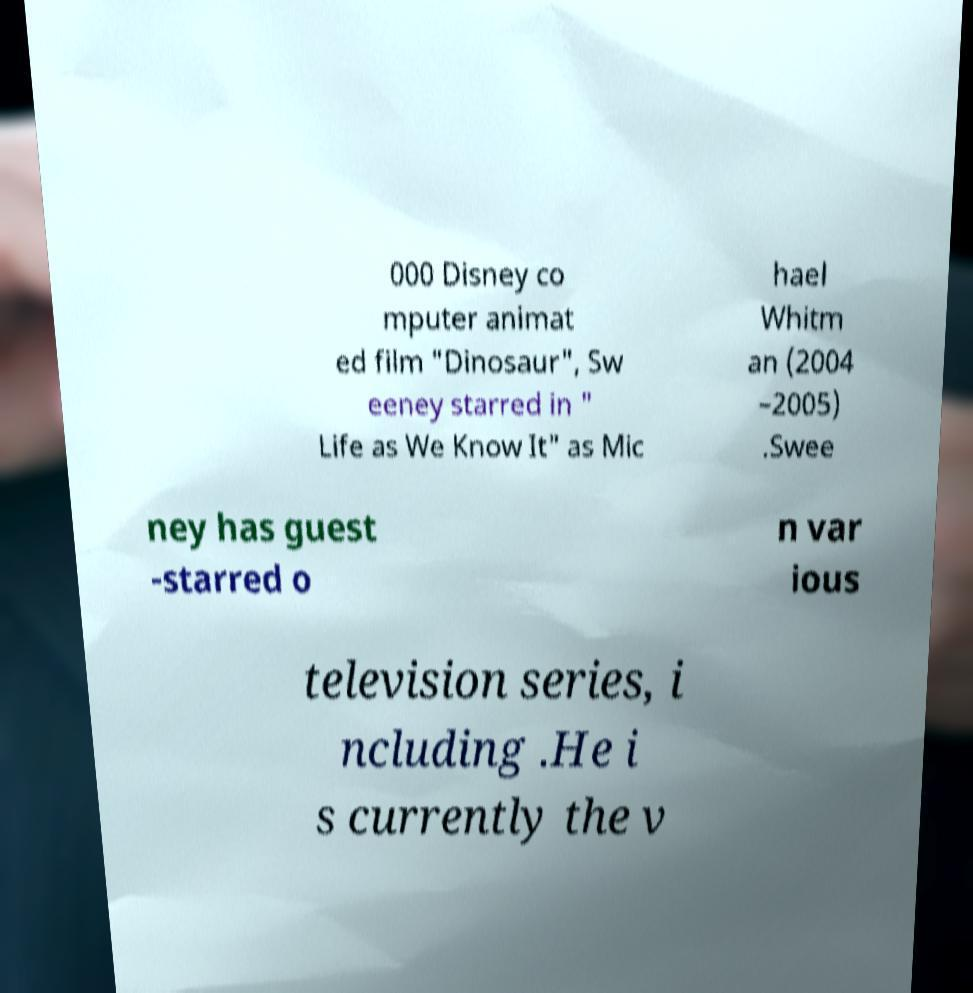Could you extract and type out the text from this image? 000 Disney co mputer animat ed film "Dinosaur", Sw eeney starred in " Life as We Know It" as Mic hael Whitm an (2004 –2005) .Swee ney has guest -starred o n var ious television series, i ncluding .He i s currently the v 